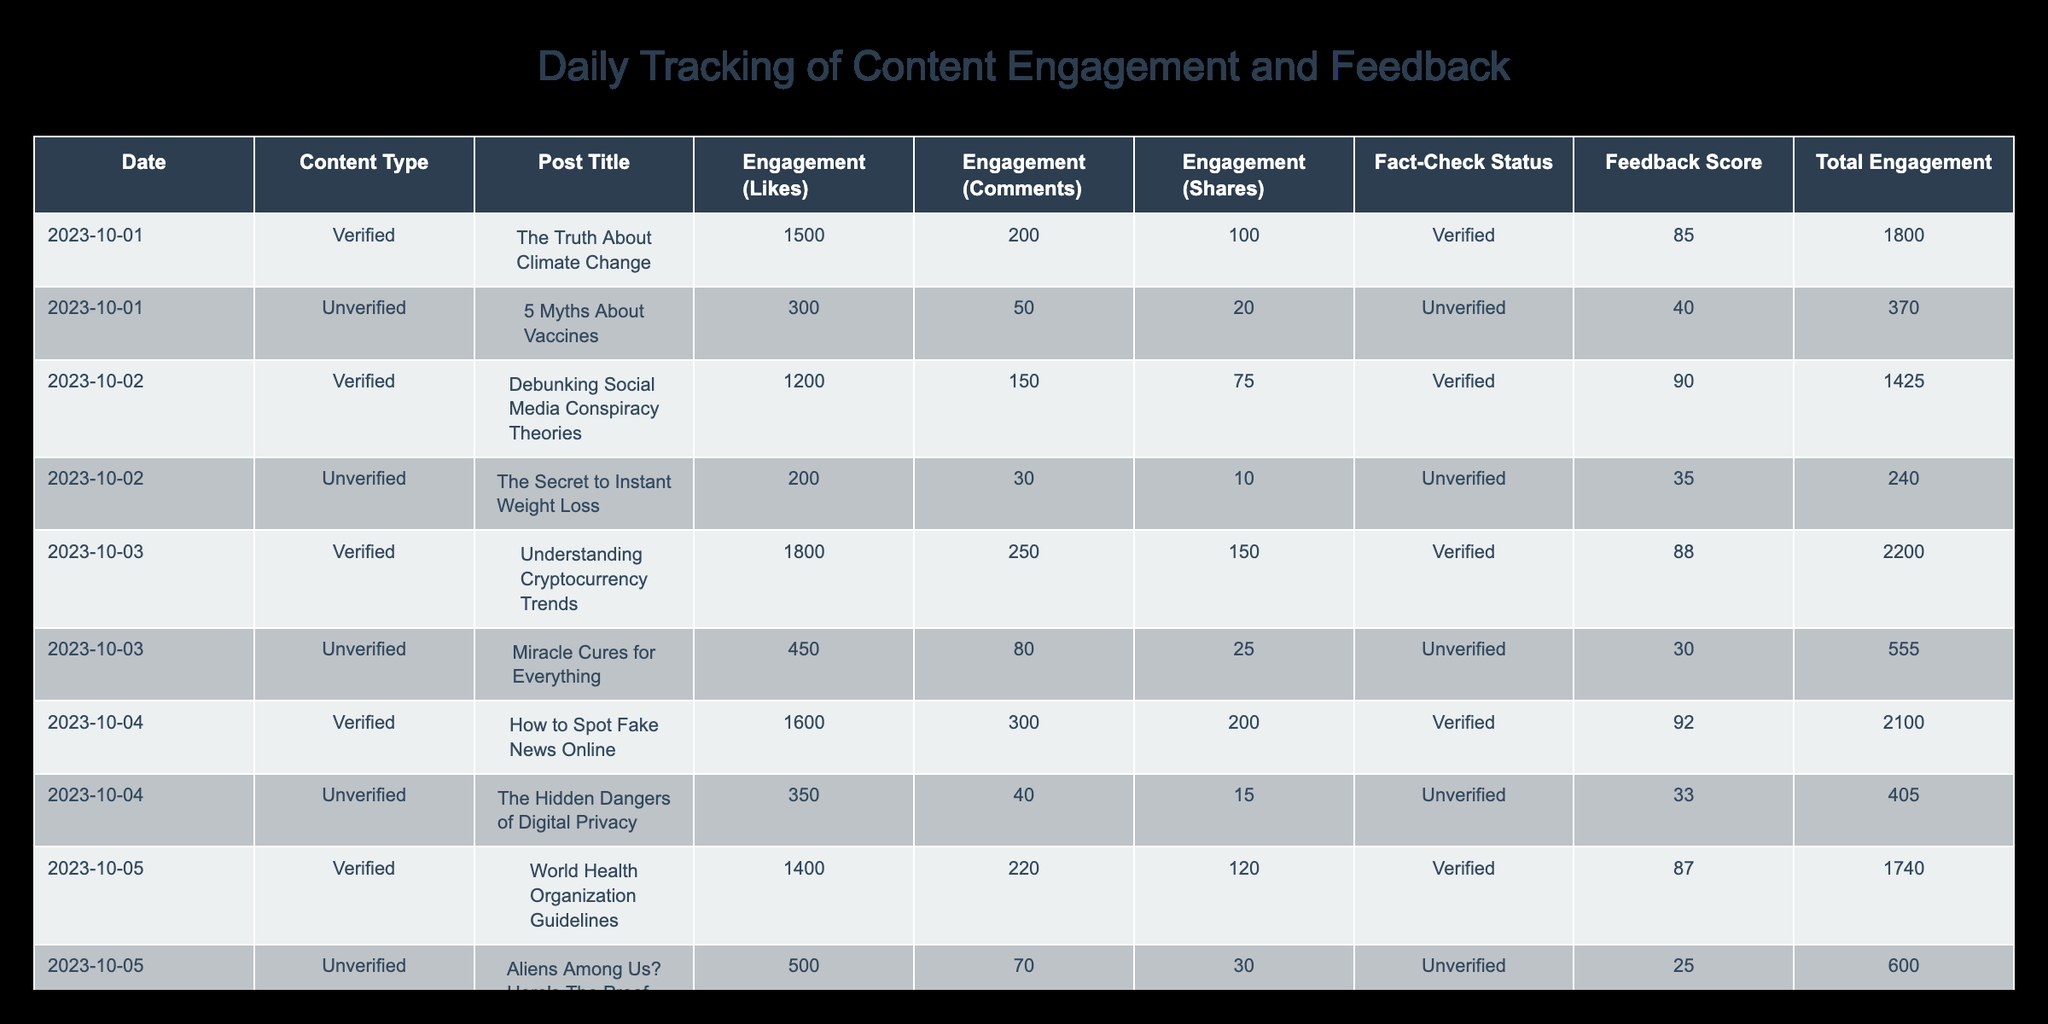What was the highest feedback score for verified content? The highest feedback score for verified content can be found by looking at the 'Feedback Score' column specifically for the rows marked as 'Verified'. Scanning through the scores, the highest score is 92 from the post titled "How to Spot Fake News Online" on 2023-10-04.
Answer: 92 What was the total engagement for the post titled "5 Myths About Vaccines"? To find the total engagement for this post, we need to sum the likes, comments, and shares specific to that post. The values are 300 likes, 50 comments, and 20 shares. Therefore, the total engagement is 300 + 50 + 20 = 370.
Answer: 370 Did any unverified content receive a higher engagement than verified content? To answer this, we compare the highest engagement values from both verified and unverified content. The highest engagement for verified content is from "Understanding Cryptocurrency Trends" with 2250 total engagement. In contrast, the highest engagement for unverified content ("Miracle Cures for Everything") is 555. Since 555 is less than 2250, the answer is no.
Answer: No What is the average feedback score for unverified content? To calculate the average feedback score for unverified content, we first sum all feedback scores for unverified posts, which are 40, 35, 30, 33, 25, and 28. This results in a total of 191. There are 6 unverified posts, so the average score is 191 / 6, which equals approximately 31.83.
Answer: 31.83 Which date had the most total engagement across all content? To determine the date with the highest total engagement, we sum the engagements (likes + comments + shares) for each date's posts. The total engagement for each date is calculated as follows: 2023-10-01: 1850, 2023-10-02: 1445, 2023-10-03: 1975, 2023-10-04: 2100, 2023-10-05: 1990, 2023-10-06: 2605. The maximum is 2605 from 2023-10-06, when "Innovations in Renewable Energy" was posted.
Answer: 2023-10-06 